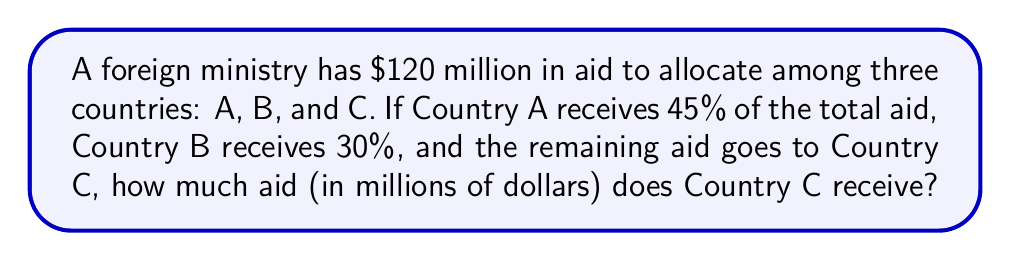What is the answer to this math problem? Let's approach this step-by-step:

1) First, let's calculate the amount of aid for Countries A and B:

   Country A: $45\% \text{ of } \$120 \text{ million} = 0.45 \times \$120 \text{ million} = \$54 \text{ million}$
   Country B: $30\% \text{ of } \$120 \text{ million} = 0.30 \times \$120 \text{ million} = \$36 \text{ million}$

2) Now, we can calculate the remaining percentage for Country C:

   $100\% - 45\% - 30\% = 25\%$

3) We can verify this by calculating the remaining amount:

   Total aid: $\$120 \text{ million}$
   Aid to A and B: $\$54 \text{ million} + \$36 \text{ million} = \$90 \text{ million}$
   Remaining for C: $\$120 \text{ million} - \$90 \text{ million} = \$30 \text{ million}$

4) We can also calculate this directly using the percentage:

   $25\% \text{ of } \$120 \text{ million} = 0.25 \times \$120 \text{ million} = \$30 \text{ million}$

Therefore, Country C receives $30 million in aid.
Answer: $30 million 